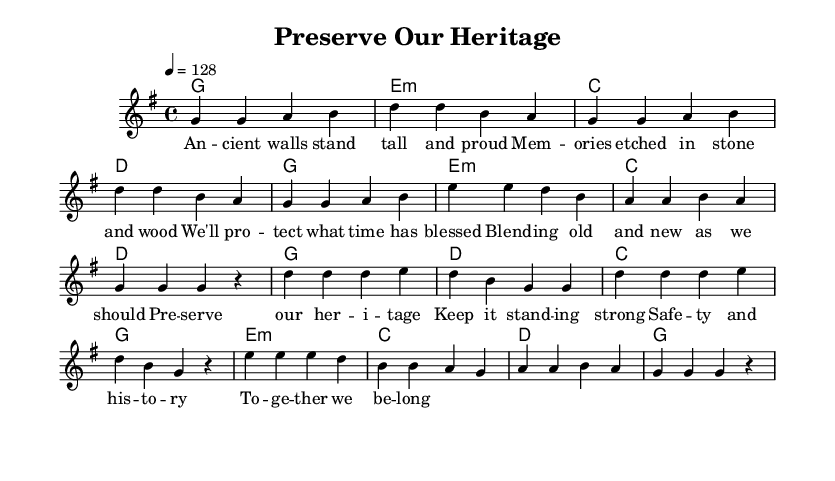What is the key signature of this music? The key signature is G major, which has one sharp included in the key signature. This is confirmed by the indication at the start of the score.
Answer: G major What is the time signature of this piece? The time signature is 4/4, as indicated in the score. It tells us that there are four beats per measure and the quarter note gets one beat.
Answer: 4/4 What is the tempo marking for this piece? The tempo marking is 128 beats per minute, which is indicated in the global section of the code. This shows how fast the piece should be played.
Answer: 128 How many measures are in the verse section? The verse section consists of 8 measures, which can be counted by segmenting the notes and looking for the bar lines that separate the measures.
Answer: 8 How many unique chords are used in the harmony section? There are 5 unique chords used in the harmony: G, E minor, C, D, and E minor again. These chords repeat throughout different sections but are the only ones used.
Answer: 5 Which section contains the lyrics "Preserve our heritage"? The lyrics "Preserve our heritage" are found in the chorus section. This can be confirmed by looking at the layout of the lyrics aligned with the melody for the chorus.
Answer: Chorus 